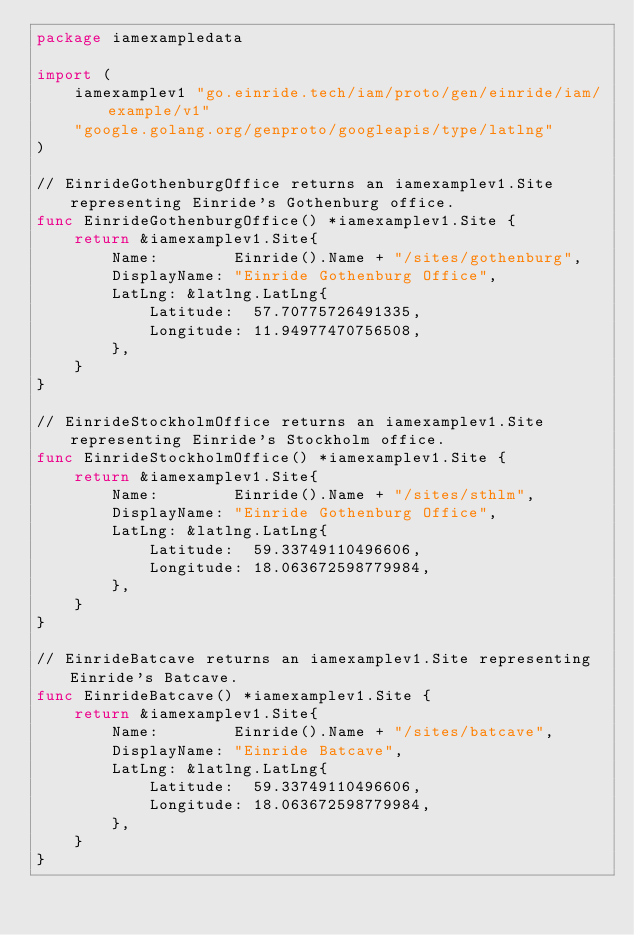<code> <loc_0><loc_0><loc_500><loc_500><_Go_>package iamexampledata

import (
	iamexamplev1 "go.einride.tech/iam/proto/gen/einride/iam/example/v1"
	"google.golang.org/genproto/googleapis/type/latlng"
)

// EinrideGothenburgOffice returns an iamexamplev1.Site representing Einride's Gothenburg office.
func EinrideGothenburgOffice() *iamexamplev1.Site {
	return &iamexamplev1.Site{
		Name:        Einride().Name + "/sites/gothenburg",
		DisplayName: "Einride Gothenburg Office",
		LatLng: &latlng.LatLng{
			Latitude:  57.70775726491335,
			Longitude: 11.94977470756508,
		},
	}
}

// EinrideStockholmOffice returns an iamexamplev1.Site representing Einride's Stockholm office.
func EinrideStockholmOffice() *iamexamplev1.Site {
	return &iamexamplev1.Site{
		Name:        Einride().Name + "/sites/sthlm",
		DisplayName: "Einride Gothenburg Office",
		LatLng: &latlng.LatLng{
			Latitude:  59.33749110496606,
			Longitude: 18.063672598779984,
		},
	}
}

// EinrideBatcave returns an iamexamplev1.Site representing Einride's Batcave.
func EinrideBatcave() *iamexamplev1.Site {
	return &iamexamplev1.Site{
		Name:        Einride().Name + "/sites/batcave",
		DisplayName: "Einride Batcave",
		LatLng: &latlng.LatLng{
			Latitude:  59.33749110496606,
			Longitude: 18.063672598779984,
		},
	}
}
</code> 